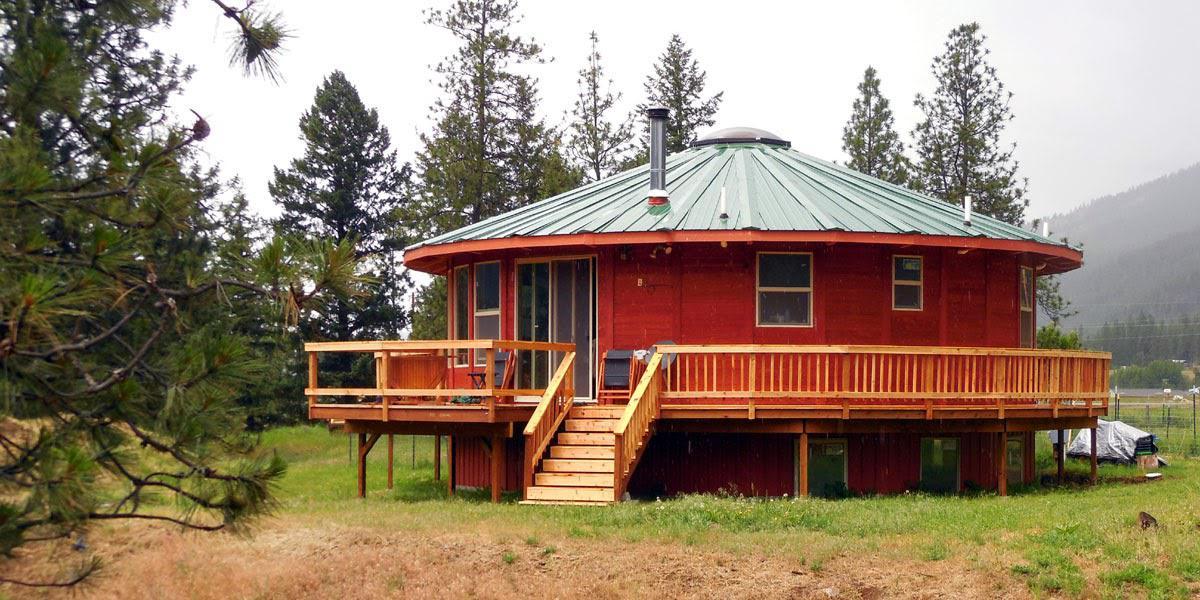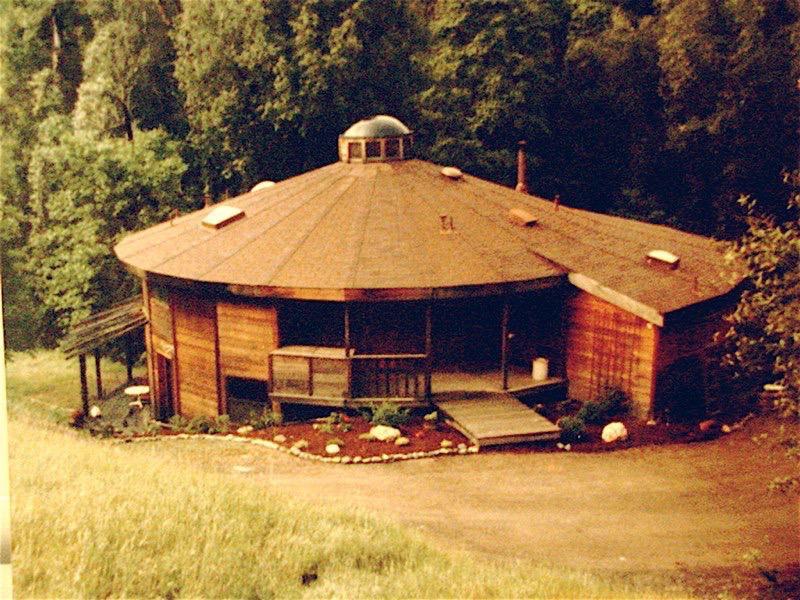The first image is the image on the left, the second image is the image on the right. Considering the images on both sides, is "The building in the picture on the left is painted red." valid? Answer yes or no. Yes. 